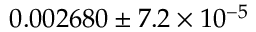<formula> <loc_0><loc_0><loc_500><loc_500>0 . 0 0 2 6 8 0 \pm 7 . 2 \times 1 0 ^ { - 5 }</formula> 